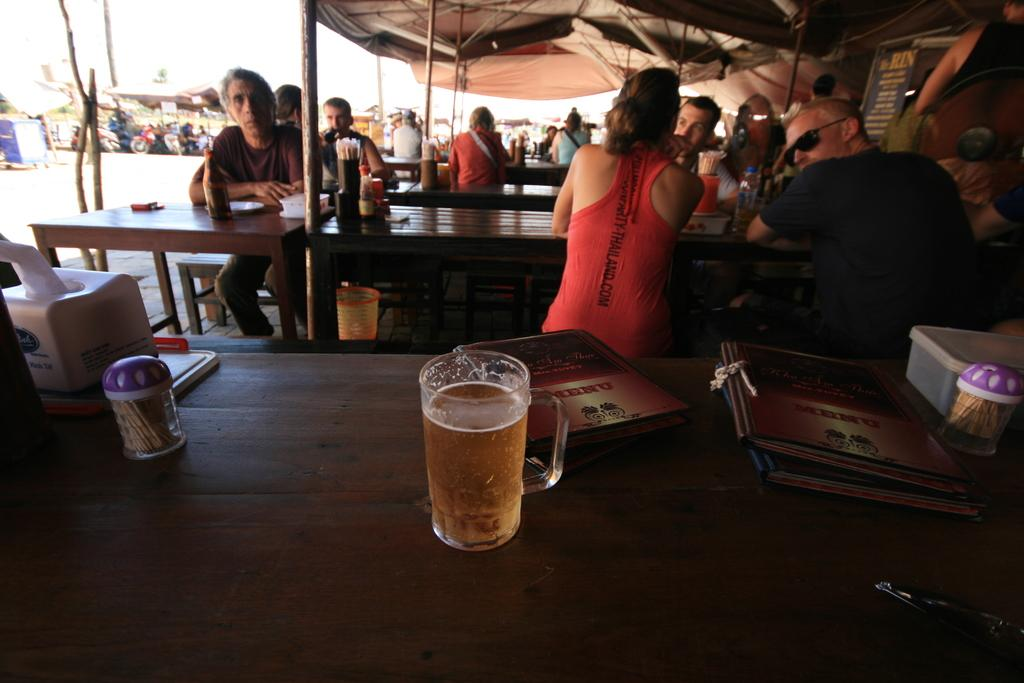What is the main activity of the people in the image? There is a group of people seated in the image. What can be seen on the table in the image? There is a beer glass and a few books on the table in the image. What type of beam is holding up the ceiling in the image? There is no beam visible in the image, as it focuses on the group of people and the objects on the table. What material is the cork made of in the image? There is no cork present in the image. --- Facts: 1. There is a person standing near a tree in the image. 2. The person is holding a camera. 3. There are leaves on the ground in the image. 4. The sky is visible in the image. Absurd Topics: parrot, sandcastle, volleyball Conversation: What is the person in the image doing? There is a person standing near a tree in the image, and they are holding a camera. What can be seen on the ground in the image? There are leaves on the ground in the image. What is visible in the background of the image? The sky is visible in the image. Reasoning: Let's think step by step in order to produce the conversation. We start by identifying the main subject in the image, which is the person standing near a tree. Then, we expand the conversation to include other items that are also visible, such as the camera, leaves on the ground, and the sky. Each question is designed to elicit a specific detail about the image that is known from the provided facts. Absurd Question/Answer: Can you tell me how many parrots are sitting on the branches of the tree in the image? There are no parrots visible on the tree in the image. What type of volleyball game is being played in the image? There is no volleyball game present in the image. 